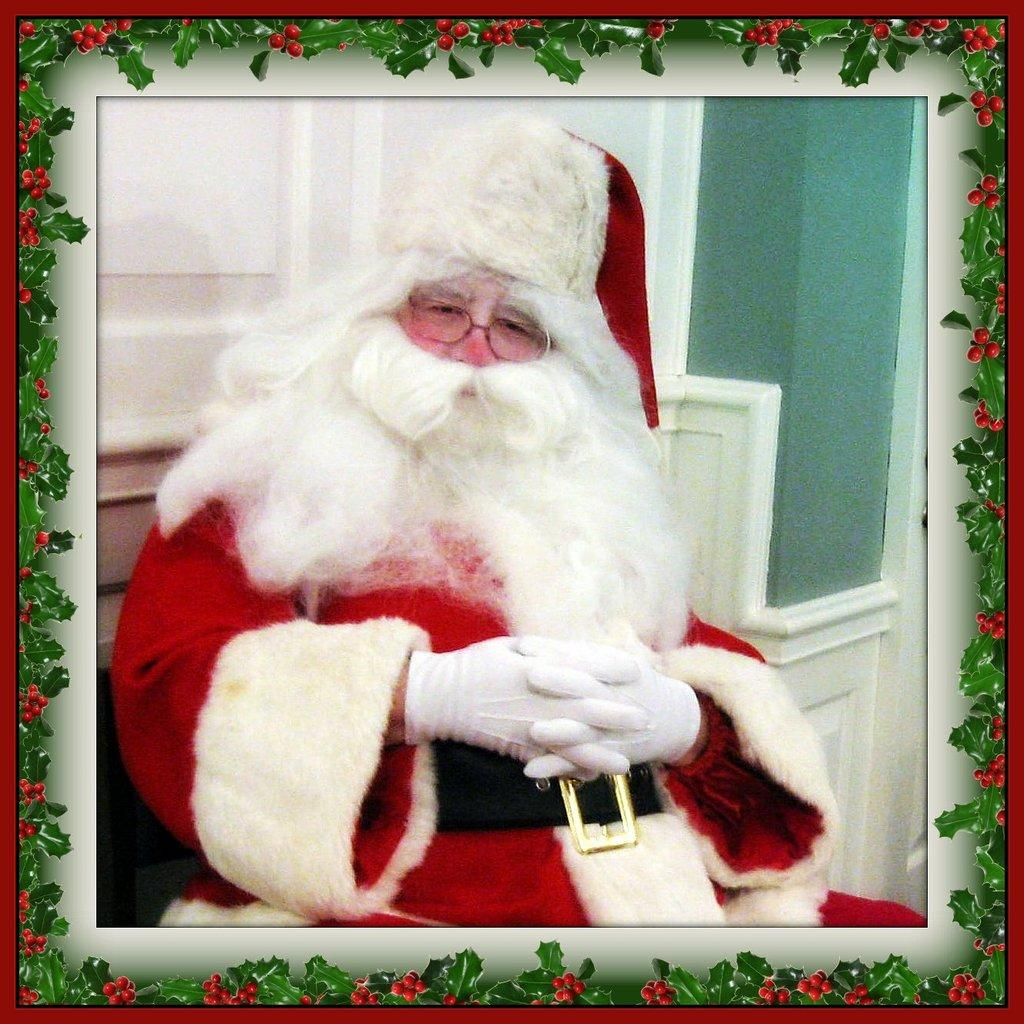What is the main subject of the image? There is a picture of Santa Claus in the image. What is Santa Claus wearing in the image? Santa Claus is wearing spectacles in the image. Where is Santa Claus sitting in the image? Santa Claus is sitting near a white door in the image. What is the color and design of the border in the image? There is a red border with green leaves and red fruits in the image. Can you tell me how many cats are visible in the image? There are no cats present in the image. What type of credit card is Santa Claus using in the image? There is no credit card or any financial transaction depicted in the image. 